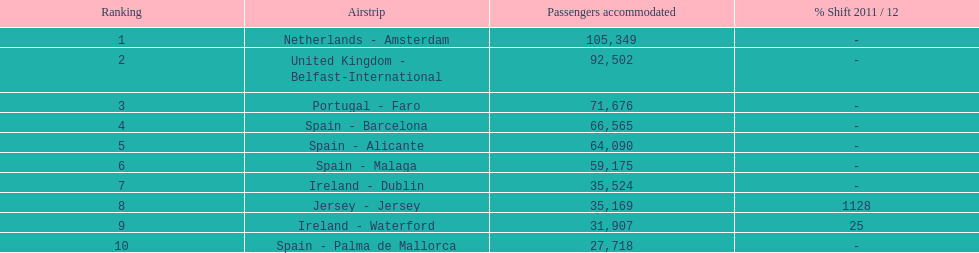What are all the passengers handled values for london southend airport? 105,349, 92,502, 71,676, 66,565, 64,090, 59,175, 35,524, 35,169, 31,907, 27,718. Which are 30,000 or less? 27,718. What airport is this for? Spain - Palma de Mallorca. 